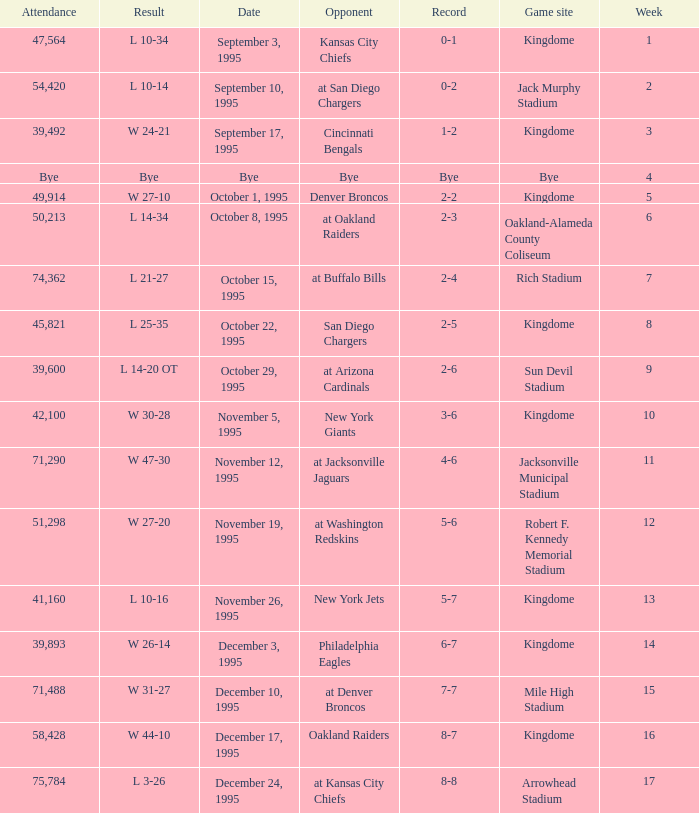Who was the opponent when the Seattle Seahawks had a record of 8-7? Oakland Raiders. 